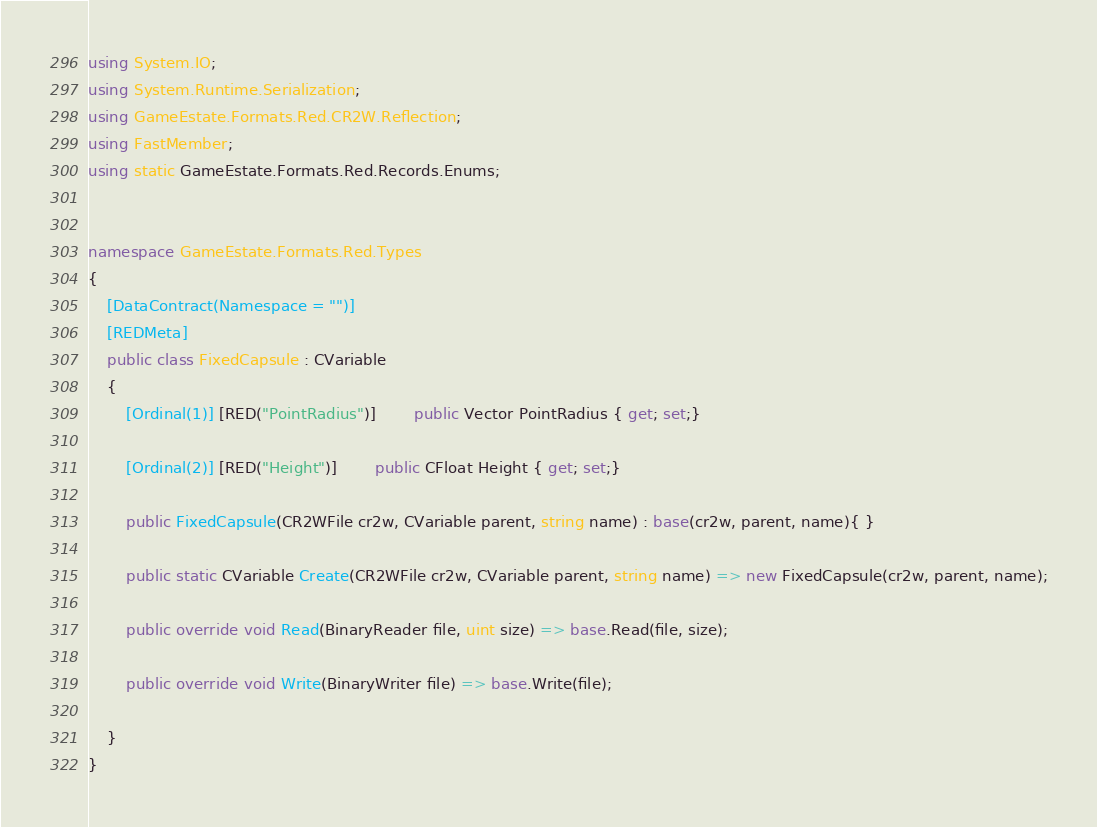Convert code to text. <code><loc_0><loc_0><loc_500><loc_500><_C#_>using System.IO;
using System.Runtime.Serialization;
using GameEstate.Formats.Red.CR2W.Reflection;
using FastMember;
using static GameEstate.Formats.Red.Records.Enums;


namespace GameEstate.Formats.Red.Types
{
	[DataContract(Namespace = "")]
	[REDMeta]
	public class FixedCapsule : CVariable
	{
		[Ordinal(1)] [RED("PointRadius")] 		public Vector PointRadius { get; set;}

		[Ordinal(2)] [RED("Height")] 		public CFloat Height { get; set;}

		public FixedCapsule(CR2WFile cr2w, CVariable parent, string name) : base(cr2w, parent, name){ }

		public static CVariable Create(CR2WFile cr2w, CVariable parent, string name) => new FixedCapsule(cr2w, parent, name);

		public override void Read(BinaryReader file, uint size) => base.Read(file, size);

		public override void Write(BinaryWriter file) => base.Write(file);

	}
}</code> 